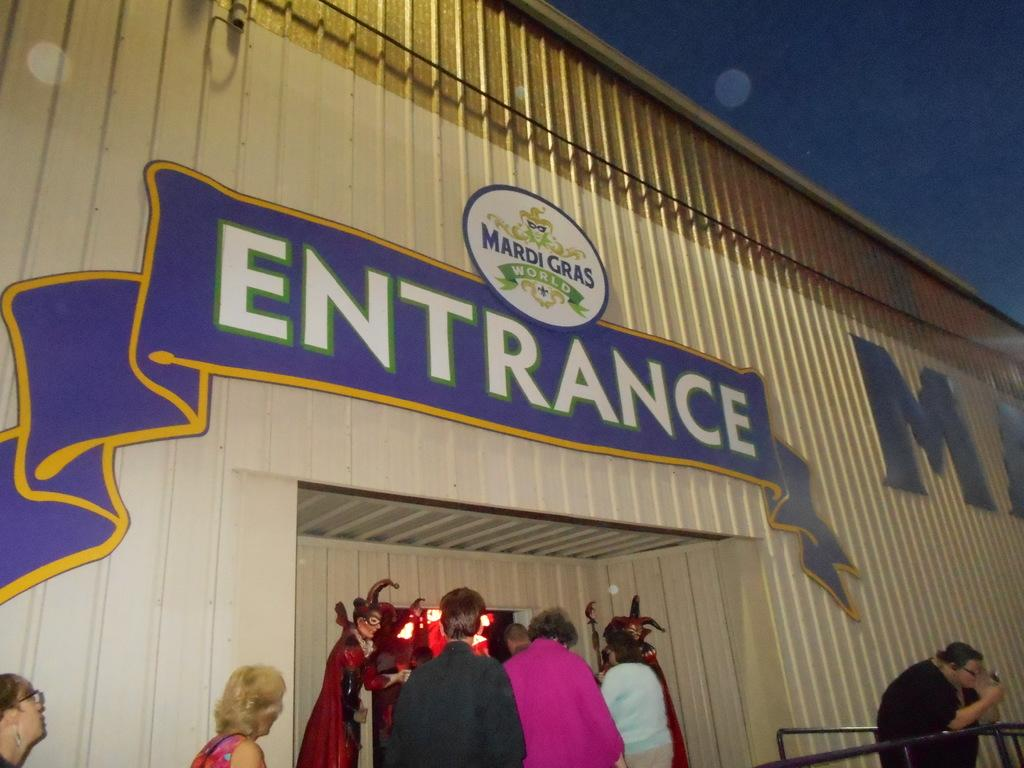<image>
Relay a brief, clear account of the picture shown. People are lined up outside the Mardi Gras World entrance. 